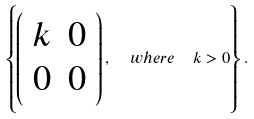<formula> <loc_0><loc_0><loc_500><loc_500>\left \{ \left ( \begin{array} { c c } k & 0 \\ 0 & 0 \end{array} \right ) , \ \ w h e r e \ \ k > 0 \right \} .</formula> 